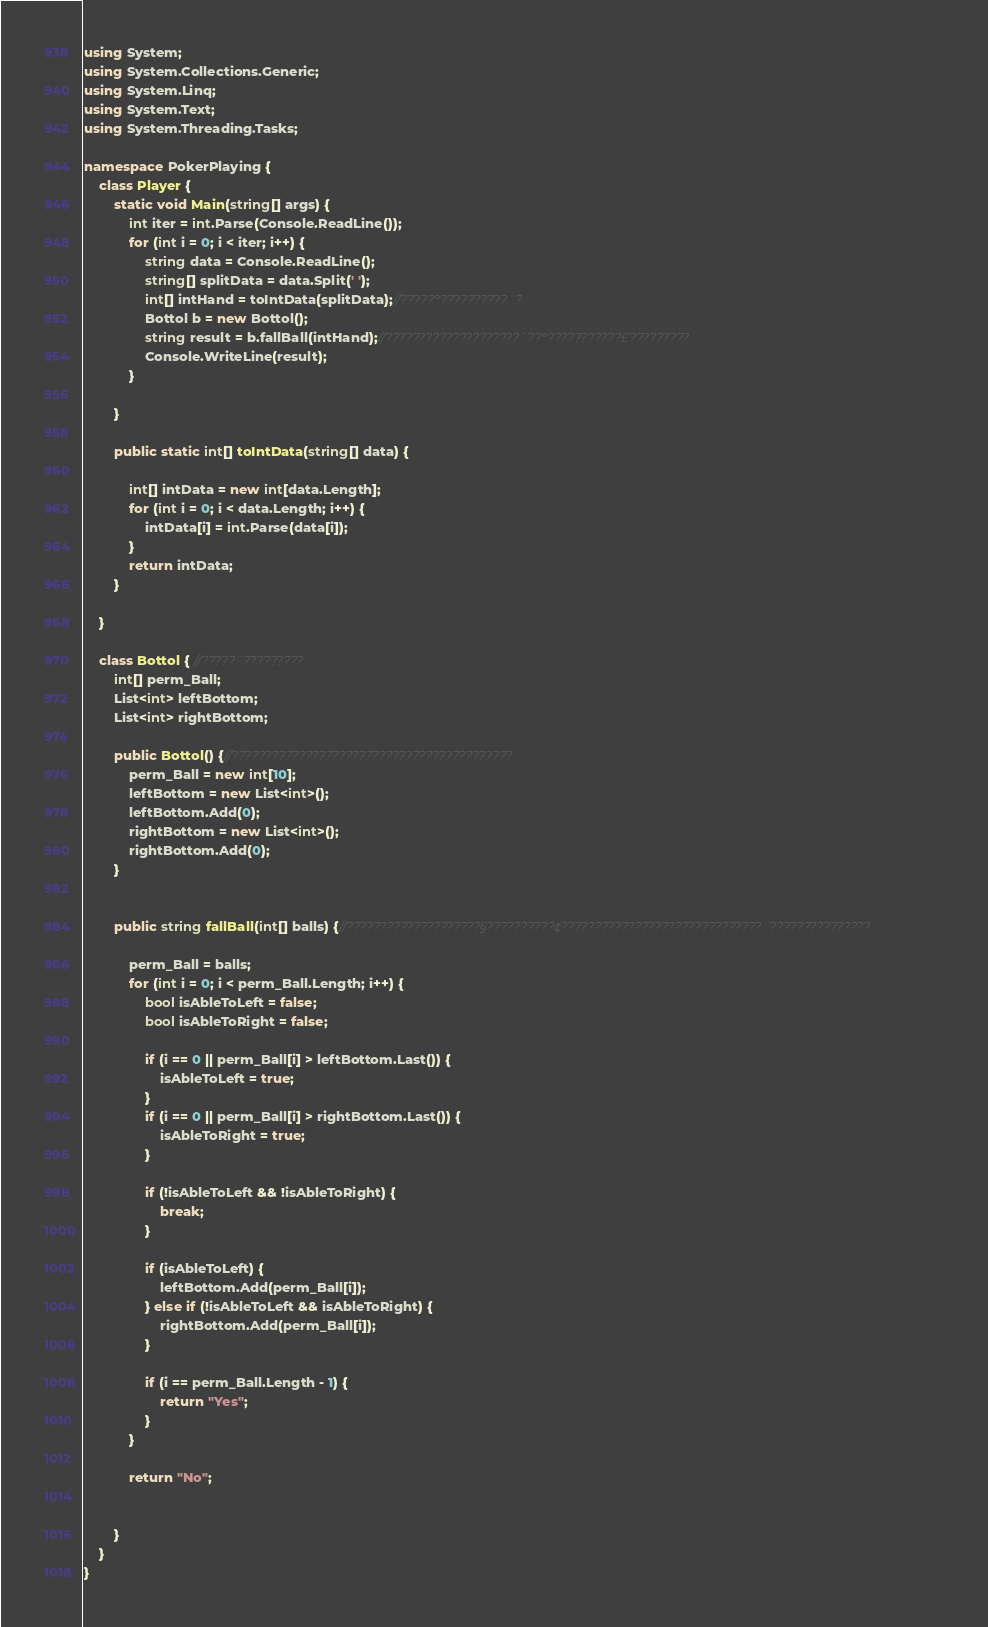Convert code to text. <code><loc_0><loc_0><loc_500><loc_500><_C#_>using System;
using System.Collections.Generic;
using System.Linq;
using System.Text;
using System.Threading.Tasks;

namespace PokerPlaying {
    class Player {
        static void Main(string[] args) {
            int iter = int.Parse(Console.ReadLine());
            for (int i = 0; i < iter; i++) {
                string data = Console.ReadLine();
                string[] splitData = data.Split(' ');
                int[] intHand = toIntData(splitData);//?????°??????????¨?
                Bottol b = new Bottol();
                string result = b.fallBall(intHand);//????????????????????´??°???????????£?????????
                Console.WriteLine(result);
            }
            
        }

        public static int[] toIntData(string[] data) {
            
            int[] intData = new int[data.Length];
            for (int i = 0; i < data.Length; i++) {
                intData[i] = int.Parse(data[i]);
            }
            return intData;
        }

    }

    class Bottol { //?????¨?????????
        int[] perm_Ball;
        List<int> leftBottom;
        List<int> rightBottom;

        public Bottol() {//??????????????????????????????????????????
            perm_Ball = new int[10];
            leftBottom = new List<int>();
            leftBottom.Add(0);
            rightBottom = new List<int>();
            rightBottom.Add(0);
        }


        public string fallBall(int[] balls) {//????????????????????§??????????¢??????????????????????????????¨???????????????

            perm_Ball = balls;
            for (int i = 0; i < perm_Ball.Length; i++) {
                bool isAbleToLeft = false;
                bool isAbleToRight = false;

                if (i == 0 || perm_Ball[i] > leftBottom.Last()) {
                    isAbleToLeft = true;
                }
                if (i == 0 || perm_Ball[i] > rightBottom.Last()) {
                    isAbleToRight = true;
                }

                if (!isAbleToLeft && !isAbleToRight) {
                    break;
                }  

                if (isAbleToLeft) {
                    leftBottom.Add(perm_Ball[i]);
                } else if (!isAbleToLeft && isAbleToRight) {
                    rightBottom.Add(perm_Ball[i]);
                }

                if (i == perm_Ball.Length - 1) {
                    return "Yes";
                }
            }
                
            return "No";
            
            
        }
    }
}</code> 